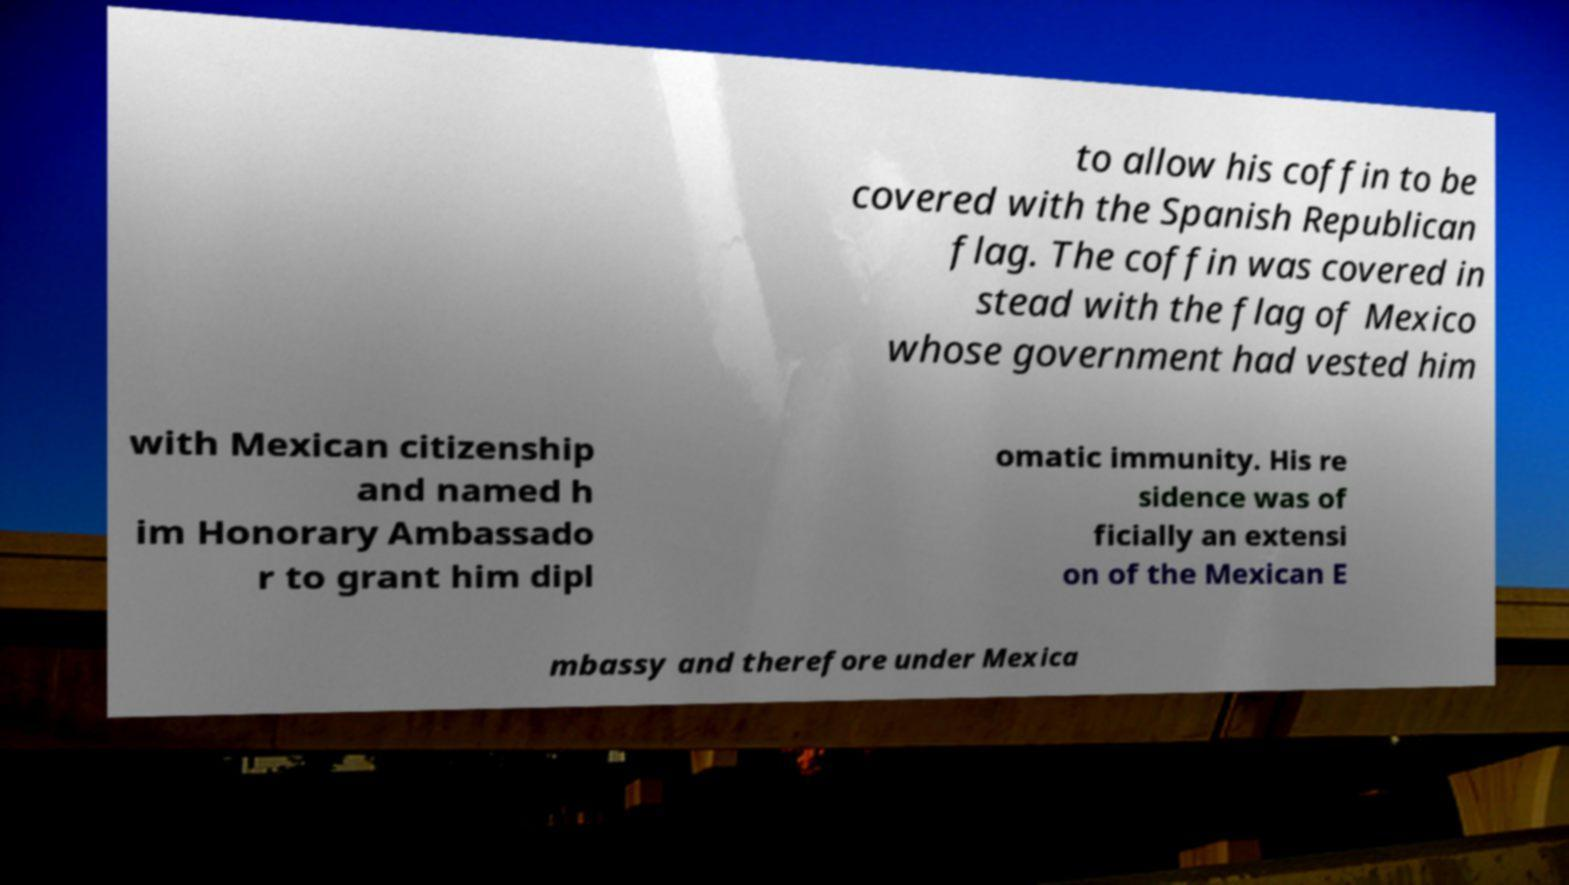Can you accurately transcribe the text from the provided image for me? to allow his coffin to be covered with the Spanish Republican flag. The coffin was covered in stead with the flag of Mexico whose government had vested him with Mexican citizenship and named h im Honorary Ambassado r to grant him dipl omatic immunity. His re sidence was of ficially an extensi on of the Mexican E mbassy and therefore under Mexica 